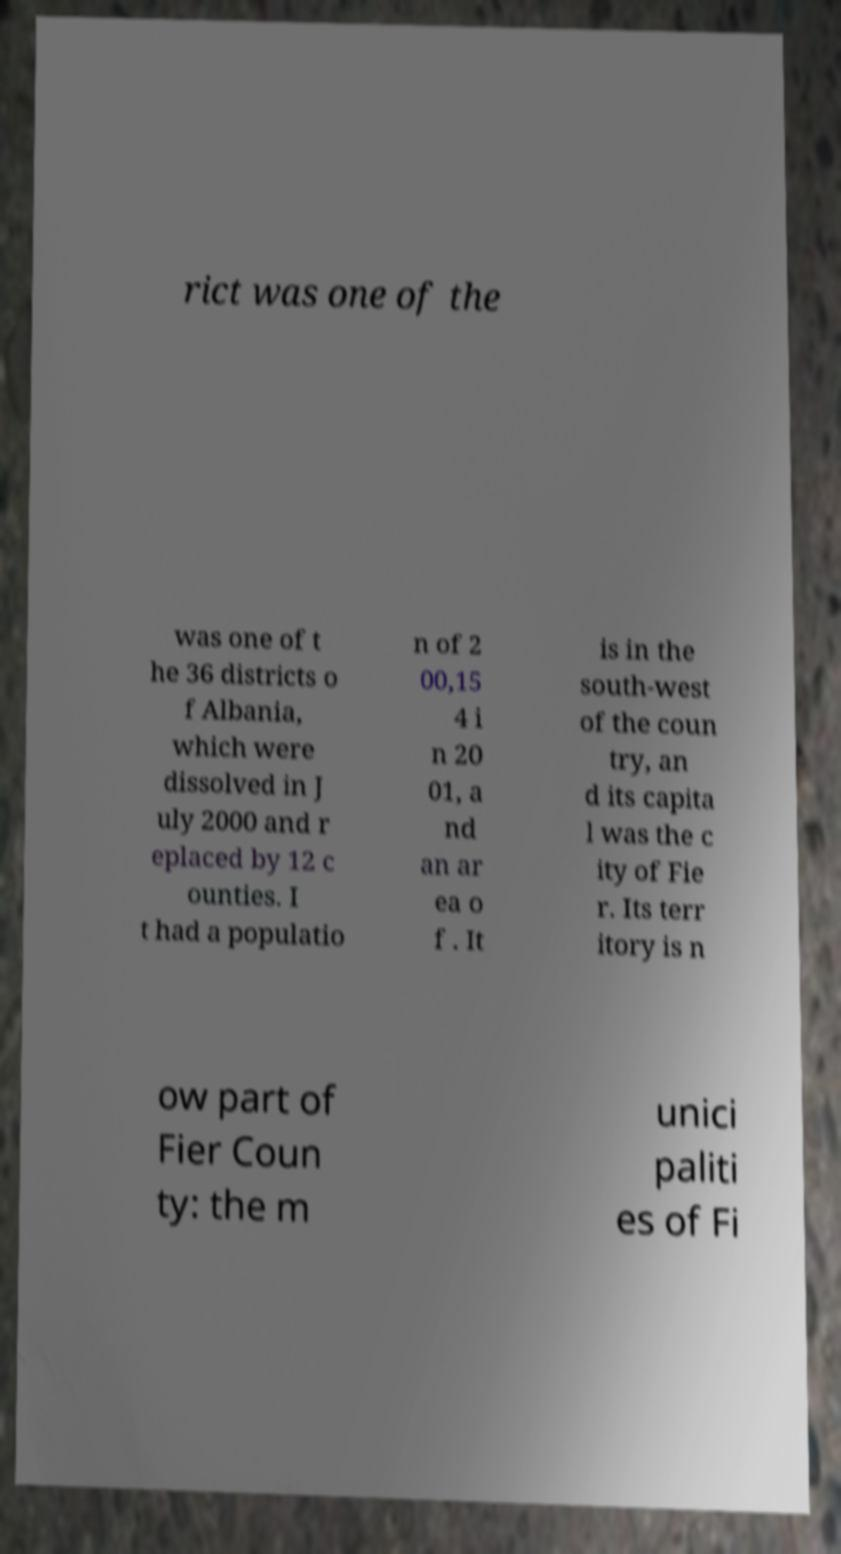I need the written content from this picture converted into text. Can you do that? rict was one of the was one of t he 36 districts o f Albania, which were dissolved in J uly 2000 and r eplaced by 12 c ounties. I t had a populatio n of 2 00,15 4 i n 20 01, a nd an ar ea o f . It is in the south-west of the coun try, an d its capita l was the c ity of Fie r. Its terr itory is n ow part of Fier Coun ty: the m unici paliti es of Fi 